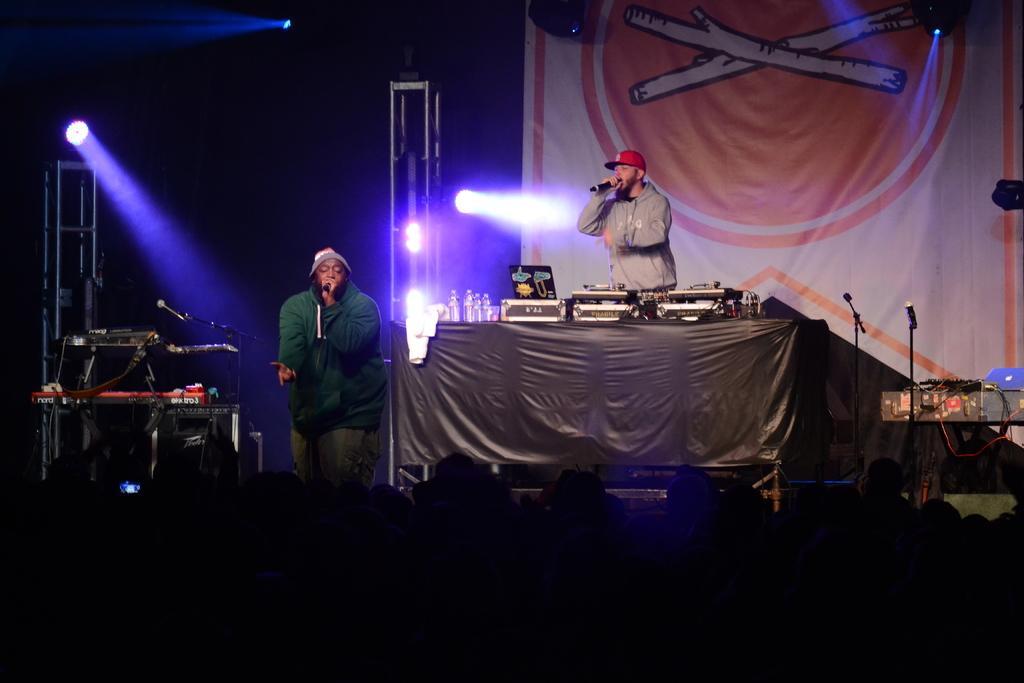Describe this image in one or two sentences. In this image in the front there are persons. In the center there are musicians performing on the stage, holding mics in their hands and there are musical instruments, bottles, mics. In the background there is a banner which is white and orange in colour and there are lights and stands. 